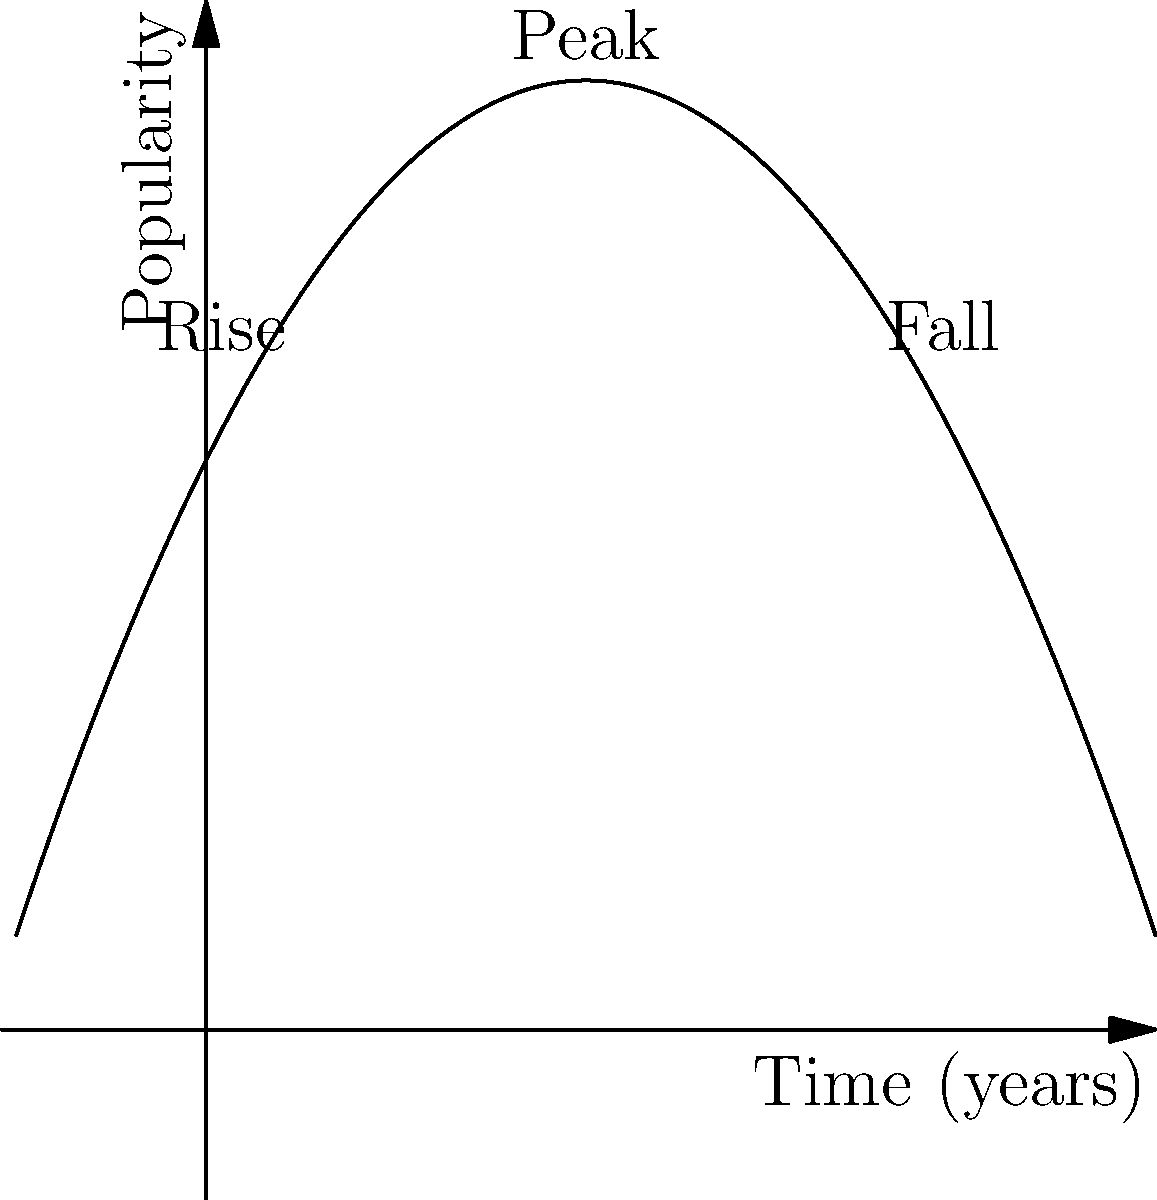A philosophical movement's popularity over time can be modeled by the quadratic function $f(x) = -0.5x^2 + 2x + 3$, where $x$ represents the number of years since the movement's inception and $f(x)$ represents its popularity. At what point in time does the movement reach its peak popularity, and what is the maximum popularity achieved? To find the peak of the parabola, we need to follow these steps:

1. The general form of a quadratic function is $f(x) = ax^2 + bx + c$, where $a$, $b$, and $c$ are constants and $a \neq 0$.

2. In this case, we have $f(x) = -0.5x^2 + 2x + 3$, so $a = -0.5$, $b = 2$, and $c = 3$.

3. The x-coordinate of the vertex (peak) of a parabola is given by the formula $x = -\frac{b}{2a}$.

4. Substituting our values:
   $x = -\frac{2}{2(-0.5)} = -\frac{2}{-1} = 2$

5. To find the y-coordinate (maximum popularity), we substitute $x = 2$ into the original function:
   $f(2) = -0.5(2)^2 + 2(2) + 3$
   $= -0.5(4) + 4 + 3$
   $= -2 + 4 + 3$
   $= 5$

Therefore, the movement reaches its peak popularity after 2 years, and the maximum popularity achieved is 5 units.
Answer: (2, 5) 